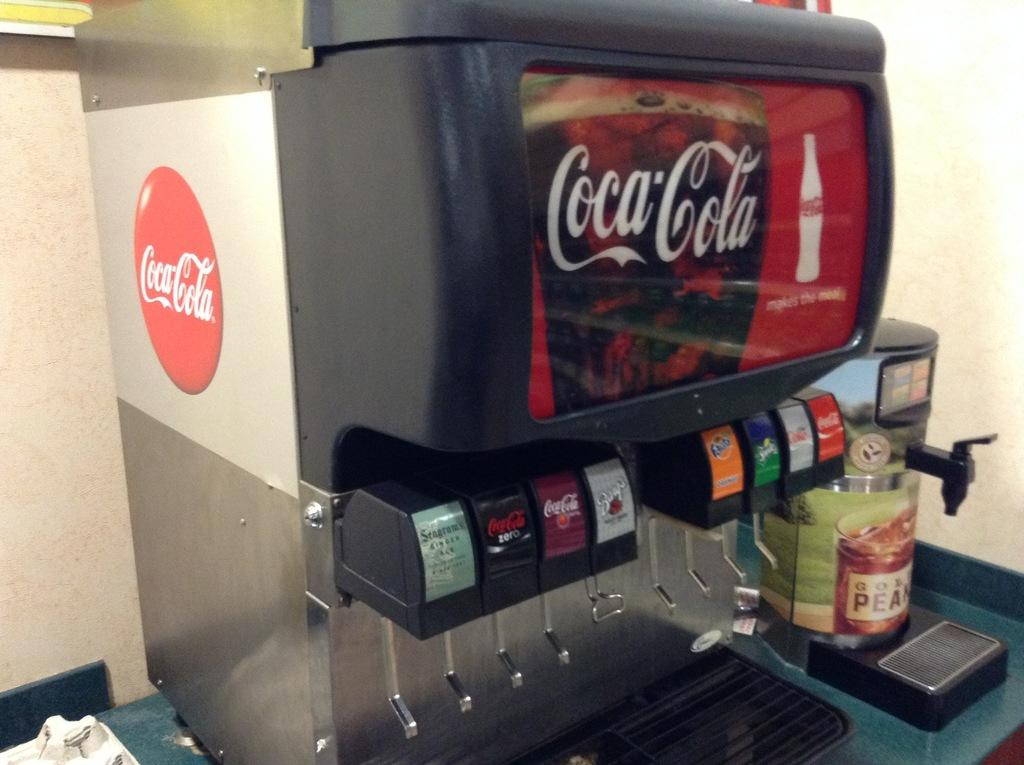Provide a one-sentence caption for the provided image. a soda fountain with the coca cola logo on it. 